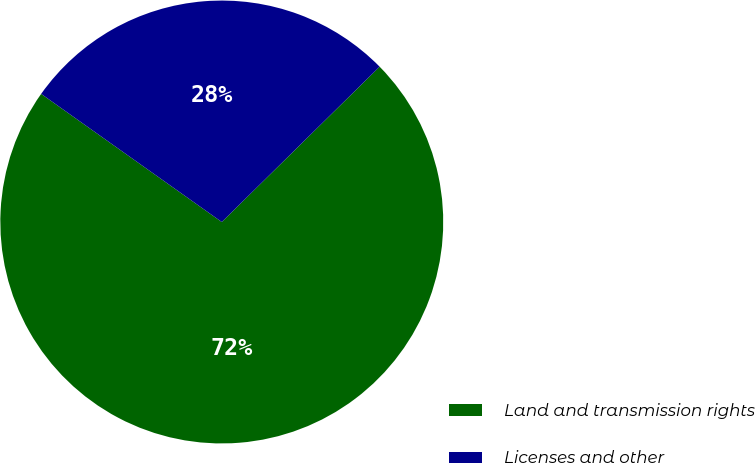Convert chart. <chart><loc_0><loc_0><loc_500><loc_500><pie_chart><fcel>Land and transmission rights<fcel>Licenses and other<nl><fcel>72.19%<fcel>27.81%<nl></chart> 